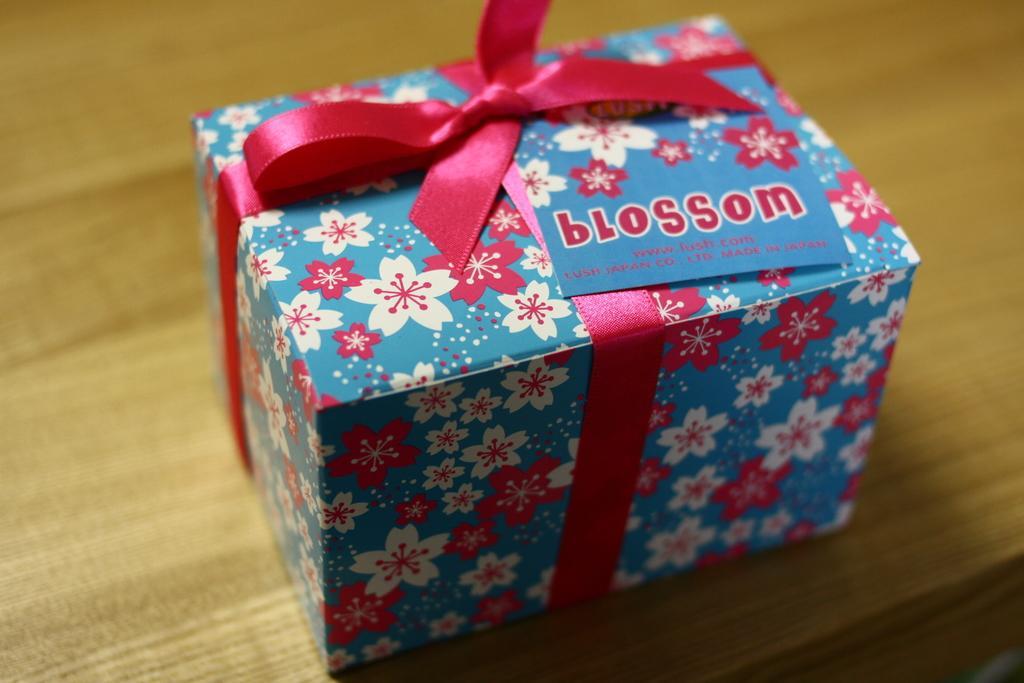Please provide a concise description of this image. In this image, I can see a gift box with a card on it. This is a ribbon, which is pink in color. This gift box is placed on the wooden table. 